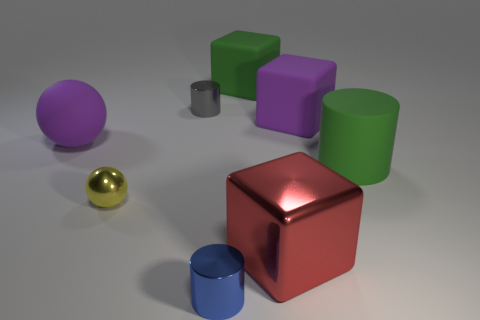What can you tell about the lighting in the scene? The scene is illuminated with what seems to be a single overhead light source, casting soft shadows directly below each object. This lighting setup results in diffused shadows with soft edges, suggesting an indoor environment possibly within a studio setting. 